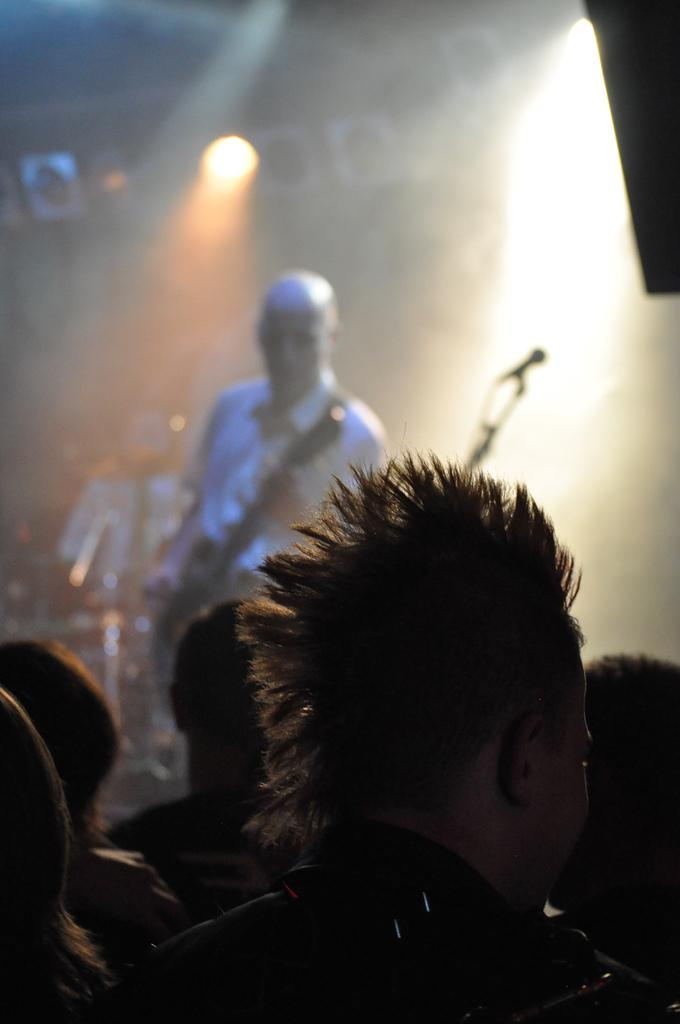How many people are in the image? There are several persons in the image. What is one of the persons doing in the background? There is a person playing a musical instrument in the background. What can be seen in the background besides the person playing the instrument? There are lights visible in the background. What type of request can be heard from the person playing the musical instrument in the image? There is no indication in the image that the person playing the musical instrument is making any requests. 